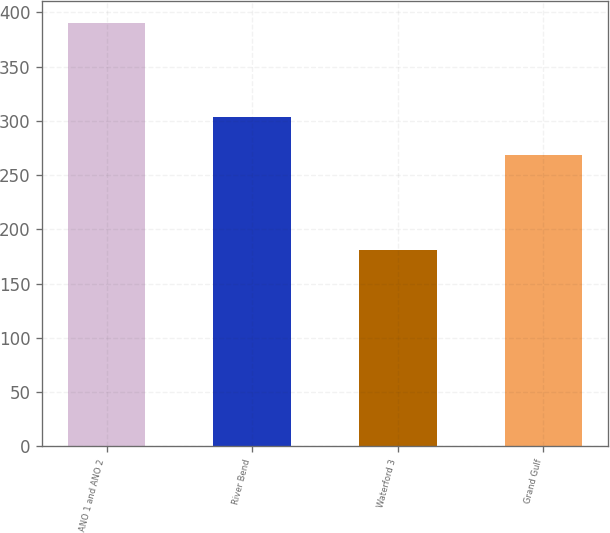Convert chart to OTSL. <chart><loc_0><loc_0><loc_500><loc_500><bar_chart><fcel>ANO 1 and ANO 2<fcel>River Bend<fcel>Waterford 3<fcel>Grand Gulf<nl><fcel>390.5<fcel>303.2<fcel>180.9<fcel>268.8<nl></chart> 